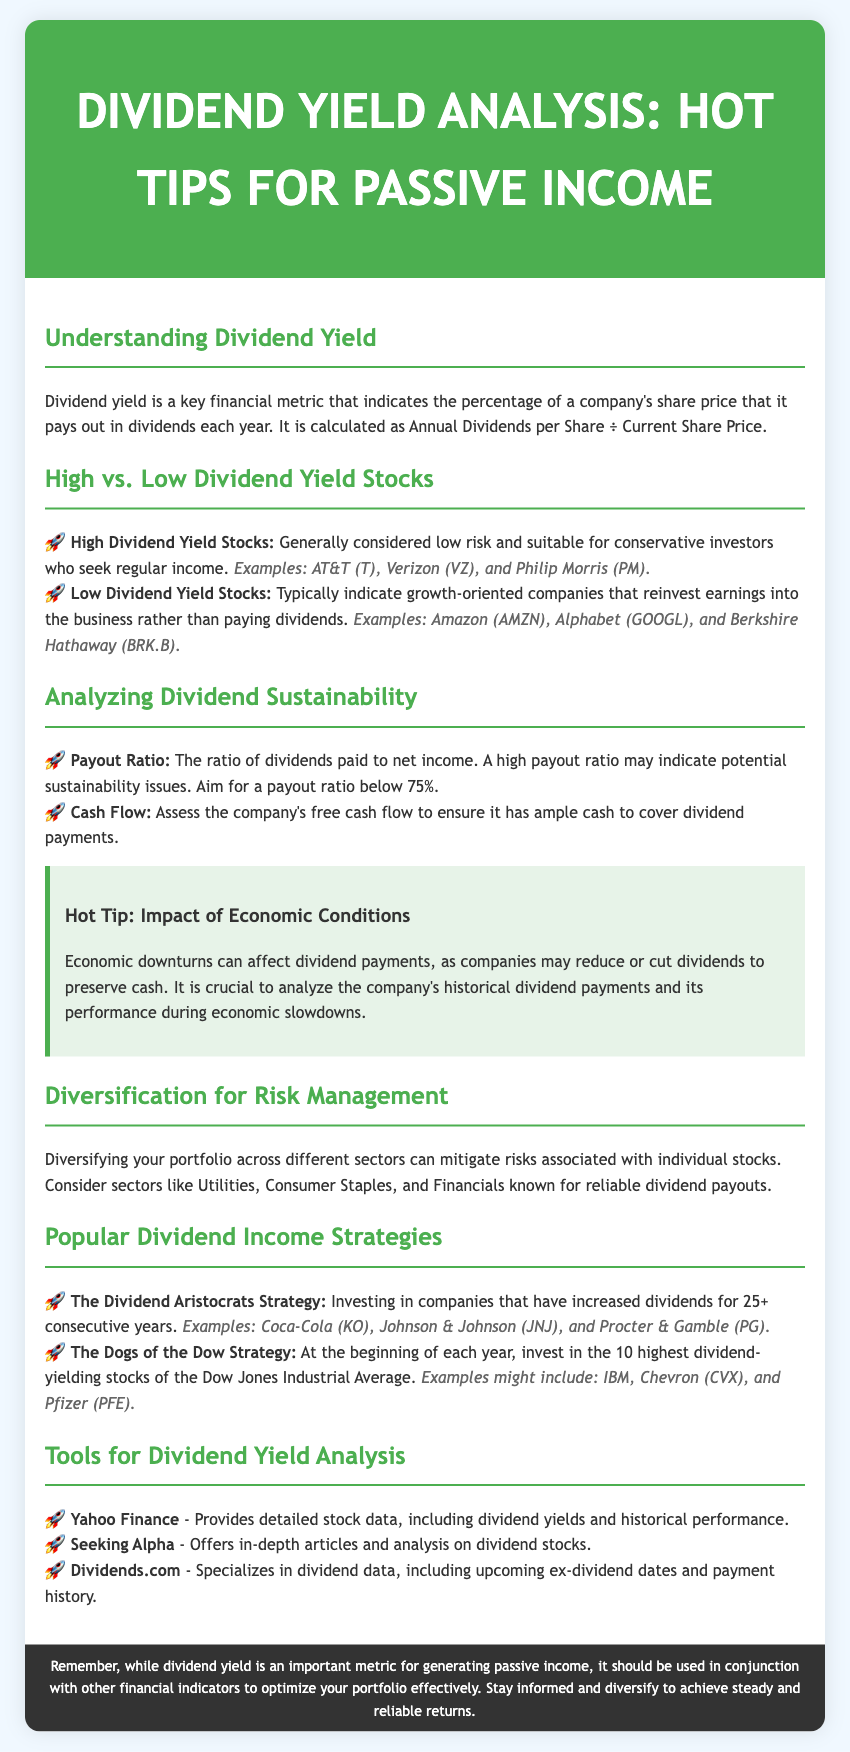What is a key financial metric discussed in the document? The document identifies dividend yield as a key financial metric indicated in the introduction section.
Answer: dividend yield What is the maximum payout ratio suggested for dividend sustainability? The document mentions that a high payout ratio may indicate potential sustainability issues and suggests aiming for below 75%.
Answer: 75% Which companies are considered examples of High Dividend Yield Stocks? The document provides specific examples of High Dividend Yield Stocks under that section, including AT&T, Verizon, and Philip Morris.
Answer: AT&T, Verizon, Philip Morris What is one popular strategy mentioned for dividend income? The document outlines strategies for generating dividend income, specifically the Dividend Aristocrats Strategy.
Answer: Dividend Aristocrats Strategy What should investors analyze during economic downturns according to the tips? The document advises analyzing the company's historical dividend payments and its performance during economic slowdowns.
Answer: historical dividend payments Which tool is mentioned for accessing dividend yield data? The document lists several tools used for analysis, one of which is Yahoo Finance.
Answer: Yahoo Finance What type of stocks are characterized as typically reinvesting earnings? The document describes Low Dividend Yield Stocks as companies that reinvest earnings instead of paying dividends.
Answer: Low Dividend Yield Stocks How many consecutive years should a company increase dividends to qualify for the Dividend Aristocrats Strategy? The document specifies companies that have increased dividends for 25 or more consecutive years as part of this strategy.
Answer: 25 